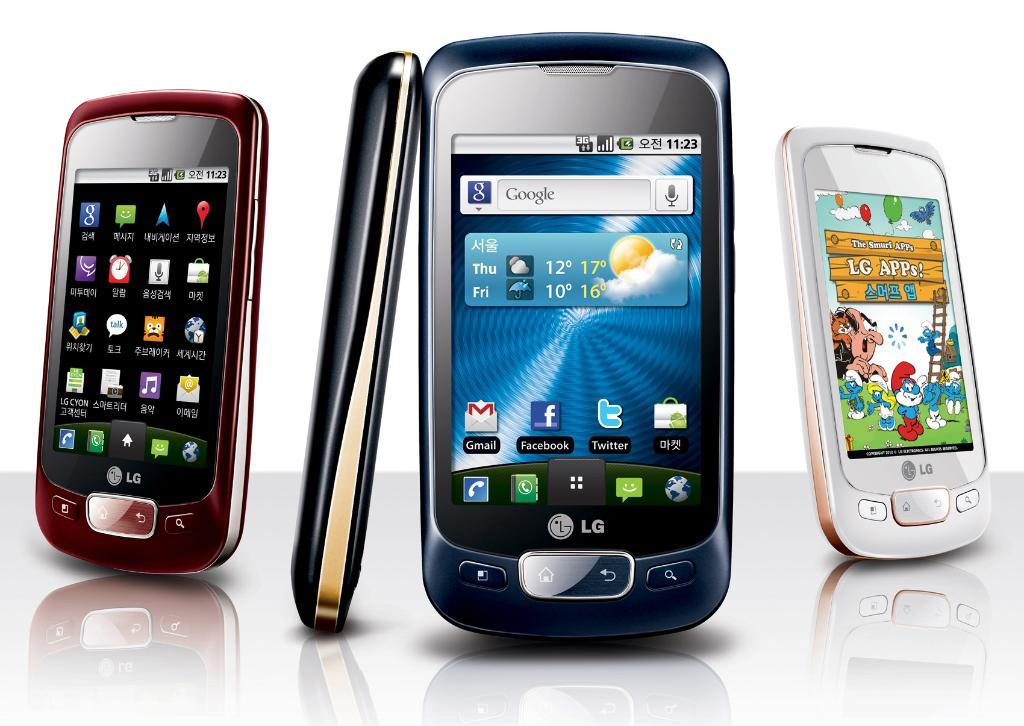<image>
Create a compact narrative representing the image presented. Several phones on display, one of which has the word google on the screen. 